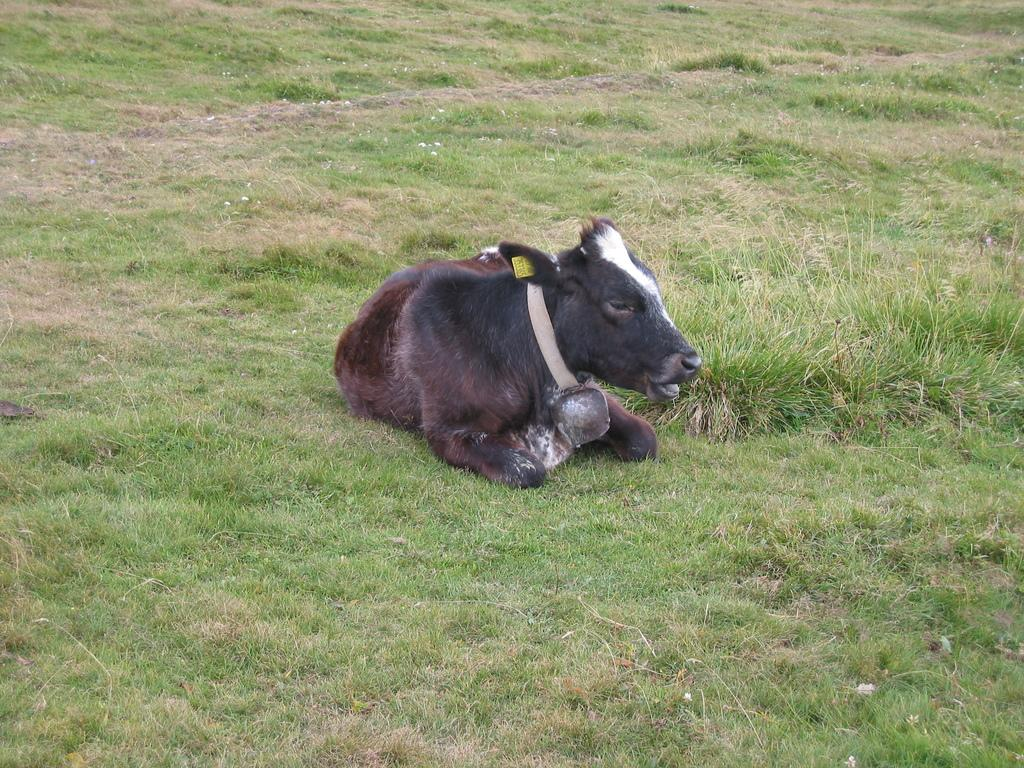What type of animal is in the image? There is a black cow baby in the image. Where is the cow baby located? The cow baby is sitting in the grass ground. What type of territory is the cow baby trying to claim in the image? There is no indication in the image that the cow baby is trying to claim any territory. 